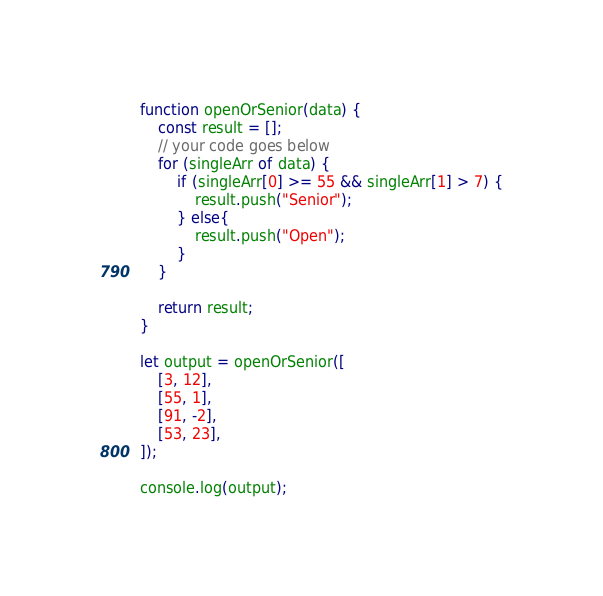<code> <loc_0><loc_0><loc_500><loc_500><_JavaScript_>function openOrSenior(data) {
    const result = [];
    // your code goes below
    for (singleArr of data) {
        if (singleArr[0] >= 55 && singleArr[1] > 7) {
            result.push("Senior");
        } else{
            result.push("Open");
        }
    }

    return result;
}

let output = openOrSenior([
    [3, 12],
    [55, 1],
    [91, -2],
    [53, 23],
]);

console.log(output);
</code> 